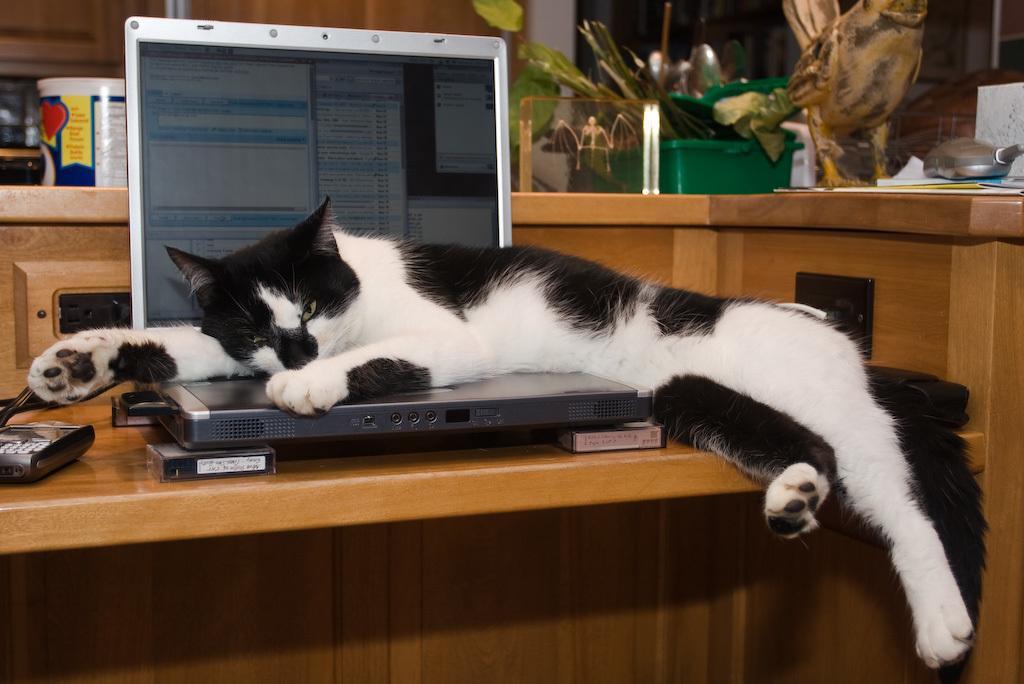Could you give a brief overview of what you see in this image? In this picture we can see a cat on the laptop. This is the screen and on the background we can see a bottle on the table. And this is the box. 